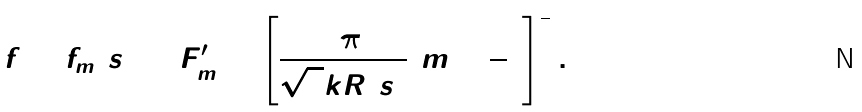<formula> <loc_0><loc_0><loc_500><loc_500>f = f _ { m } ( s ) = F _ { m } ^ { \prime } = \left [ \frac { 3 \pi } { \sqrt { 8 } k R ( s ) } ( m + \frac { 3 } { 4 } ) \right ] ^ { \frac { 2 } { 3 } } .</formula> 